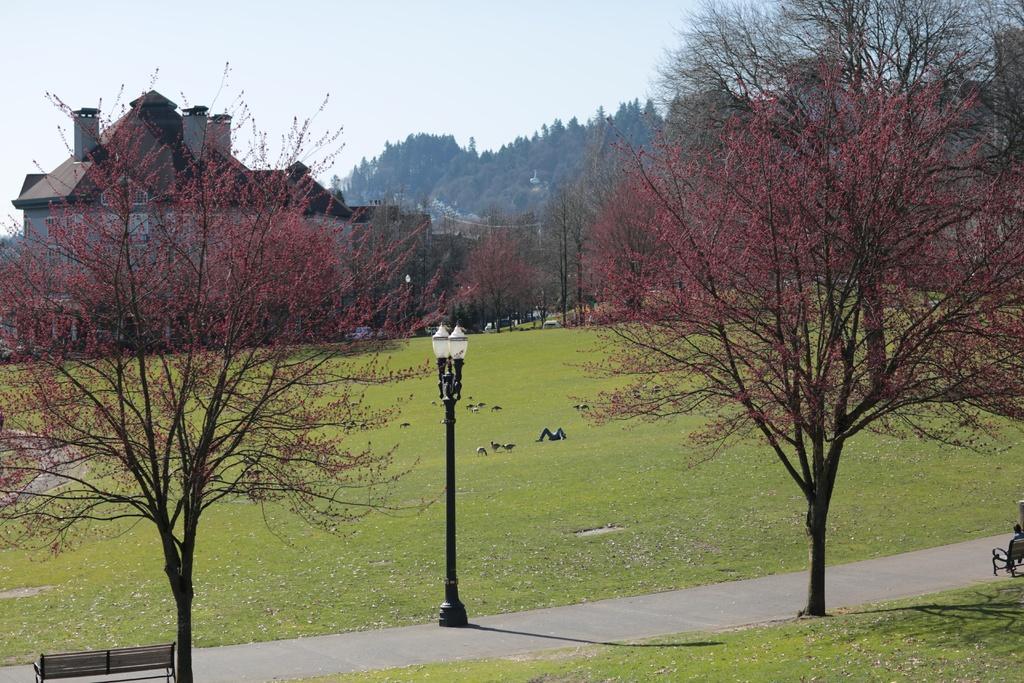How would you summarize this image in a sentence or two? In the image we can see a building, light pole, road, benches, birds, there are any trees and a sky. 